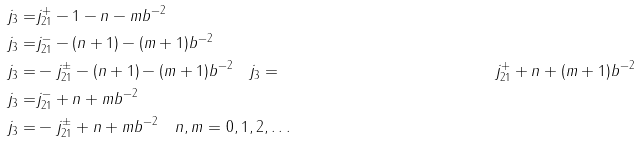Convert formula to latex. <formula><loc_0><loc_0><loc_500><loc_500>j _ { 3 } = & j _ { 2 1 } ^ { + } - 1 - n - m b ^ { - 2 } \\ j _ { 3 } = & j _ { 2 1 } ^ { - } - ( n + 1 ) - ( m + 1 ) b ^ { - 2 } \\ j _ { 3 } = & - j _ { 2 1 } ^ { \pm } - ( n + 1 ) - ( m + 1 ) b ^ { - 2 } \quad j _ { 3 } = & j _ { 2 1 } ^ { + } + n + ( m + 1 ) b ^ { - 2 } \\ j _ { 3 } = & j _ { 2 1 } ^ { - } + n + m b ^ { - 2 } \\ j _ { 3 } = & - j _ { 2 1 } ^ { \pm } + n + m b ^ { - 2 } \quad n , m = 0 , 1 , 2 , \dots</formula> 